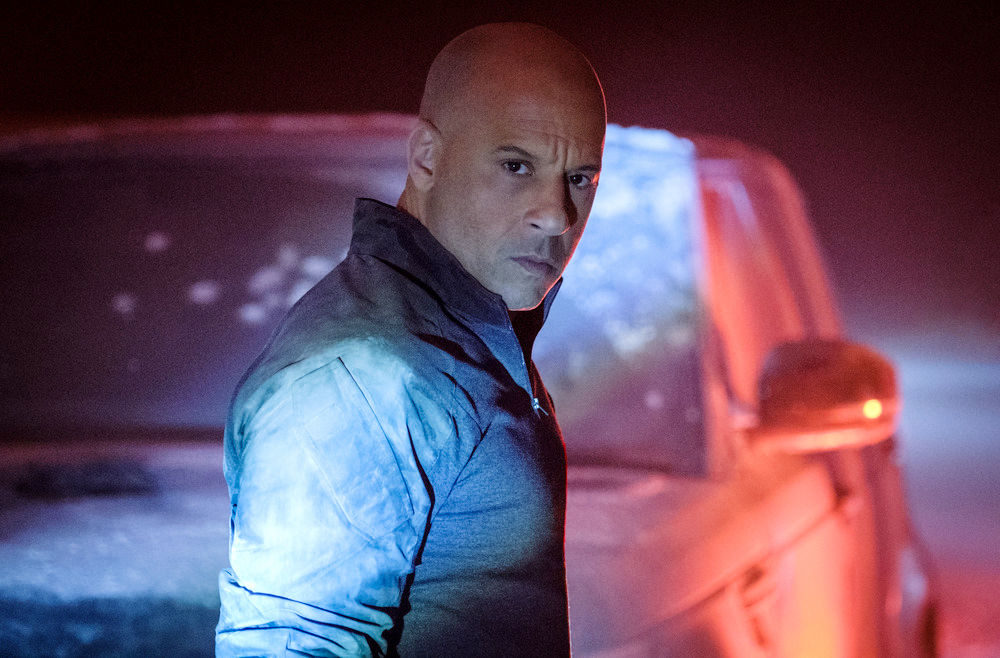What might be the mood or story depicted in this image? The image seems to portray a story or mood of suspense and anticipation. The foggy backdrop and dim lighting contribute to a mysterious or perhaps tense atmosphere, suggesting that the scene could be part of a crucial moment in a narrative, where the character is either awaiting someone or perhaps contemplating a significant decision. 